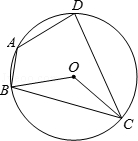Describe what you see in the figure. In the diagram, there is a quadrilateral ABCD that is inscribed within a circle labeled O. The four vertices of the quadrilateral are points A, B, C, and D. 